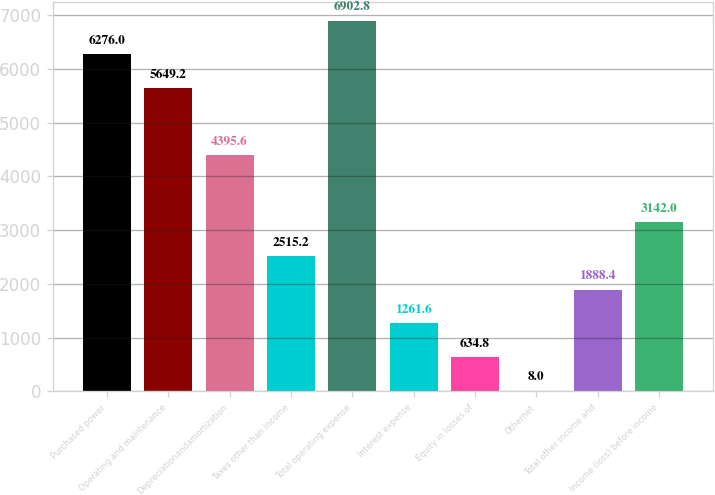Convert chart. <chart><loc_0><loc_0><loc_500><loc_500><bar_chart><fcel>Purchased power<fcel>Operating and maintenance<fcel>Depreciationandamortization<fcel>Taxes other than income<fcel>Total operating expense<fcel>Interest expense<fcel>Equity in losses of<fcel>Othernet<fcel>Total other income and<fcel>Income (loss) before income<nl><fcel>6276<fcel>5649.2<fcel>4395.6<fcel>2515.2<fcel>6902.8<fcel>1261.6<fcel>634.8<fcel>8<fcel>1888.4<fcel>3142<nl></chart> 